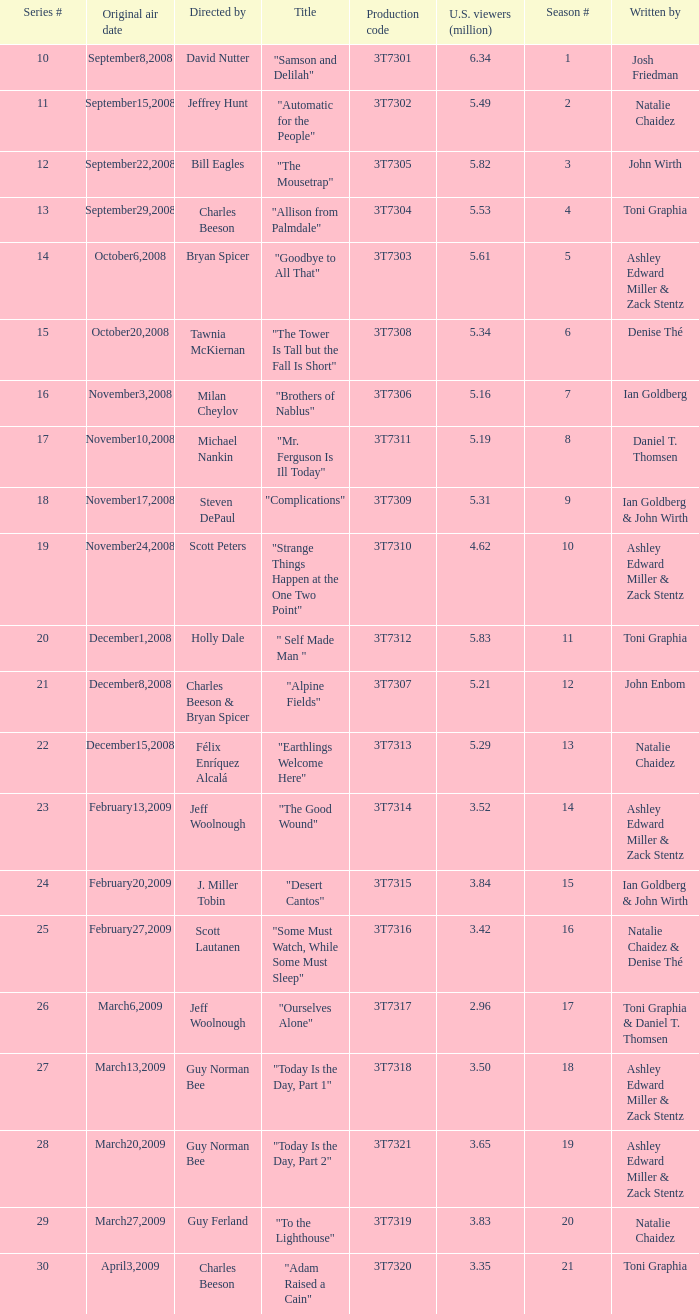Which episode number was directed by Bill Eagles? 12.0. 